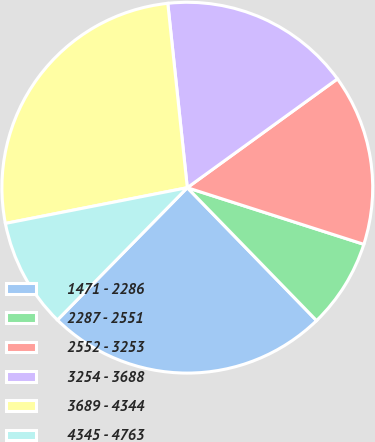Convert chart. <chart><loc_0><loc_0><loc_500><loc_500><pie_chart><fcel>1471 - 2286<fcel>2287 - 2551<fcel>2552 - 3253<fcel>3254 - 3688<fcel>3689 - 4344<fcel>4345 - 4763<nl><fcel>24.63%<fcel>7.78%<fcel>14.92%<fcel>16.7%<fcel>26.41%<fcel>9.56%<nl></chart> 